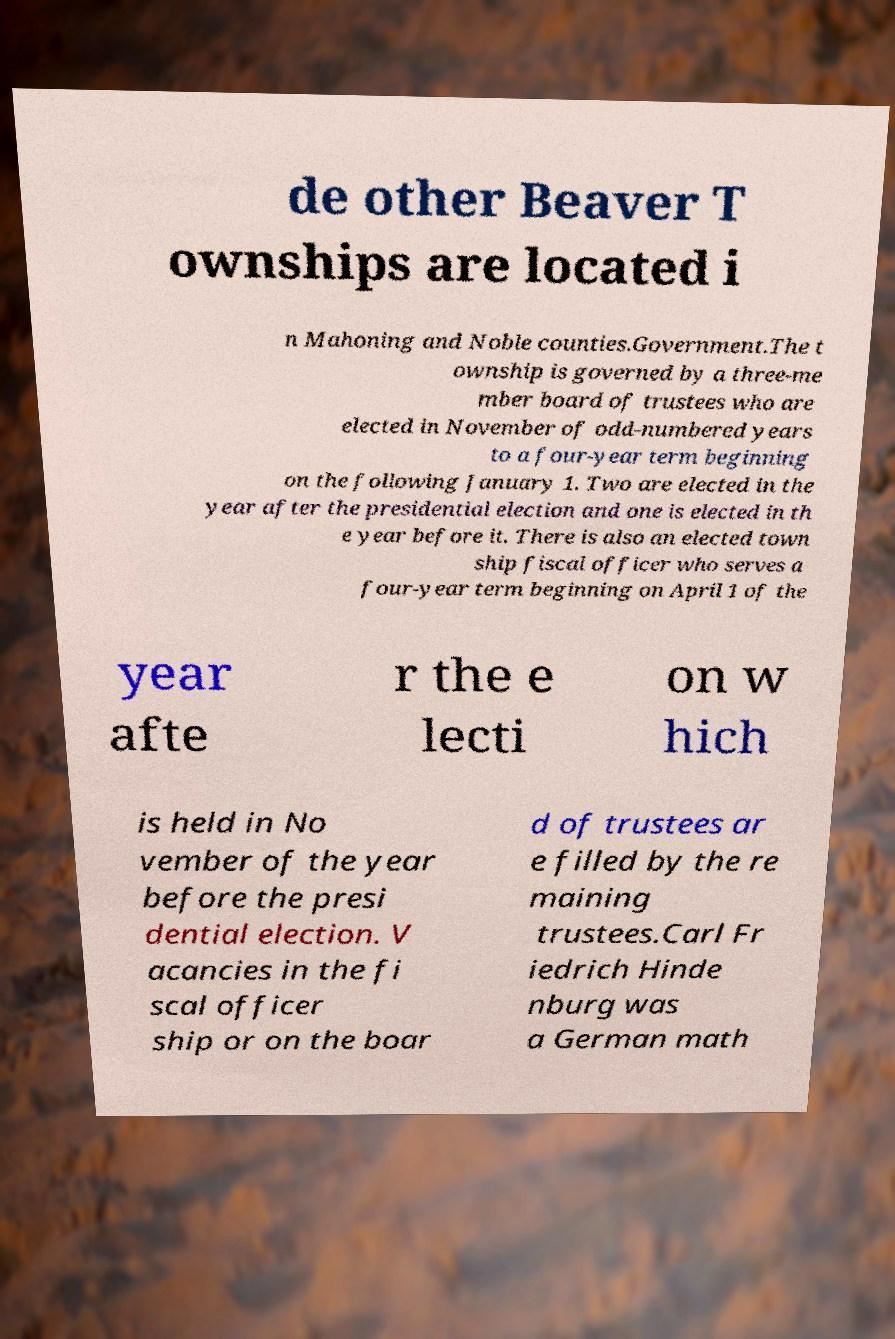There's text embedded in this image that I need extracted. Can you transcribe it verbatim? de other Beaver T ownships are located i n Mahoning and Noble counties.Government.The t ownship is governed by a three-me mber board of trustees who are elected in November of odd-numbered years to a four-year term beginning on the following January 1. Two are elected in the year after the presidential election and one is elected in th e year before it. There is also an elected town ship fiscal officer who serves a four-year term beginning on April 1 of the year afte r the e lecti on w hich is held in No vember of the year before the presi dential election. V acancies in the fi scal officer ship or on the boar d of trustees ar e filled by the re maining trustees.Carl Fr iedrich Hinde nburg was a German math 